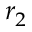Convert formula to latex. <formula><loc_0><loc_0><loc_500><loc_500>r _ { 2 }</formula> 